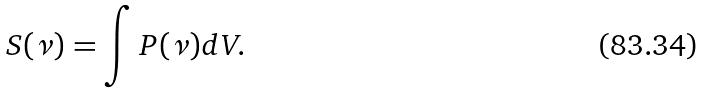<formula> <loc_0><loc_0><loc_500><loc_500>S ( \nu ) = \int P ( \nu ) d V .</formula> 